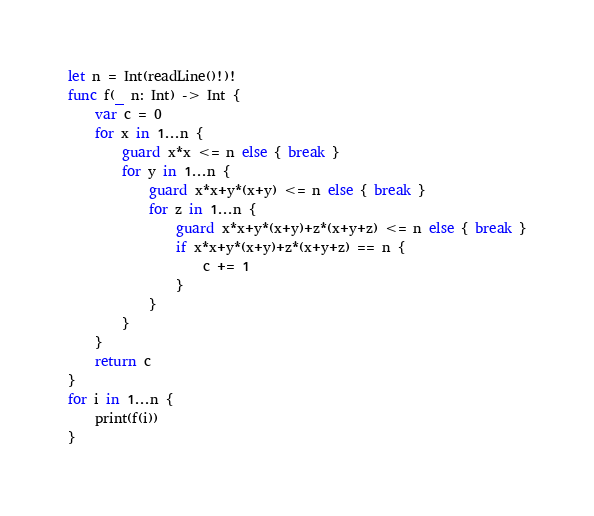Convert code to text. <code><loc_0><loc_0><loc_500><loc_500><_Swift_>let n = Int(readLine()!)!
func f(_ n: Int) -> Int {
    var c = 0
    for x in 1...n {
        guard x*x <= n else { break }
        for y in 1...n {
            guard x*x+y*(x+y) <= n else { break }
            for z in 1...n {
                guard x*x+y*(x+y)+z*(x+y+z) <= n else { break }
                if x*x+y*(x+y)+z*(x+y+z) == n {
                    c += 1
                }
            }
        }
    }
    return c
}
for i in 1...n {
    print(f(i))
}
</code> 